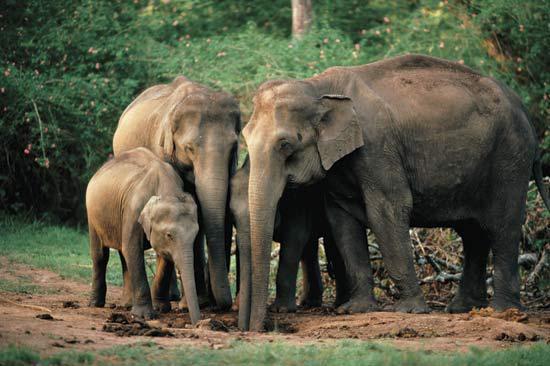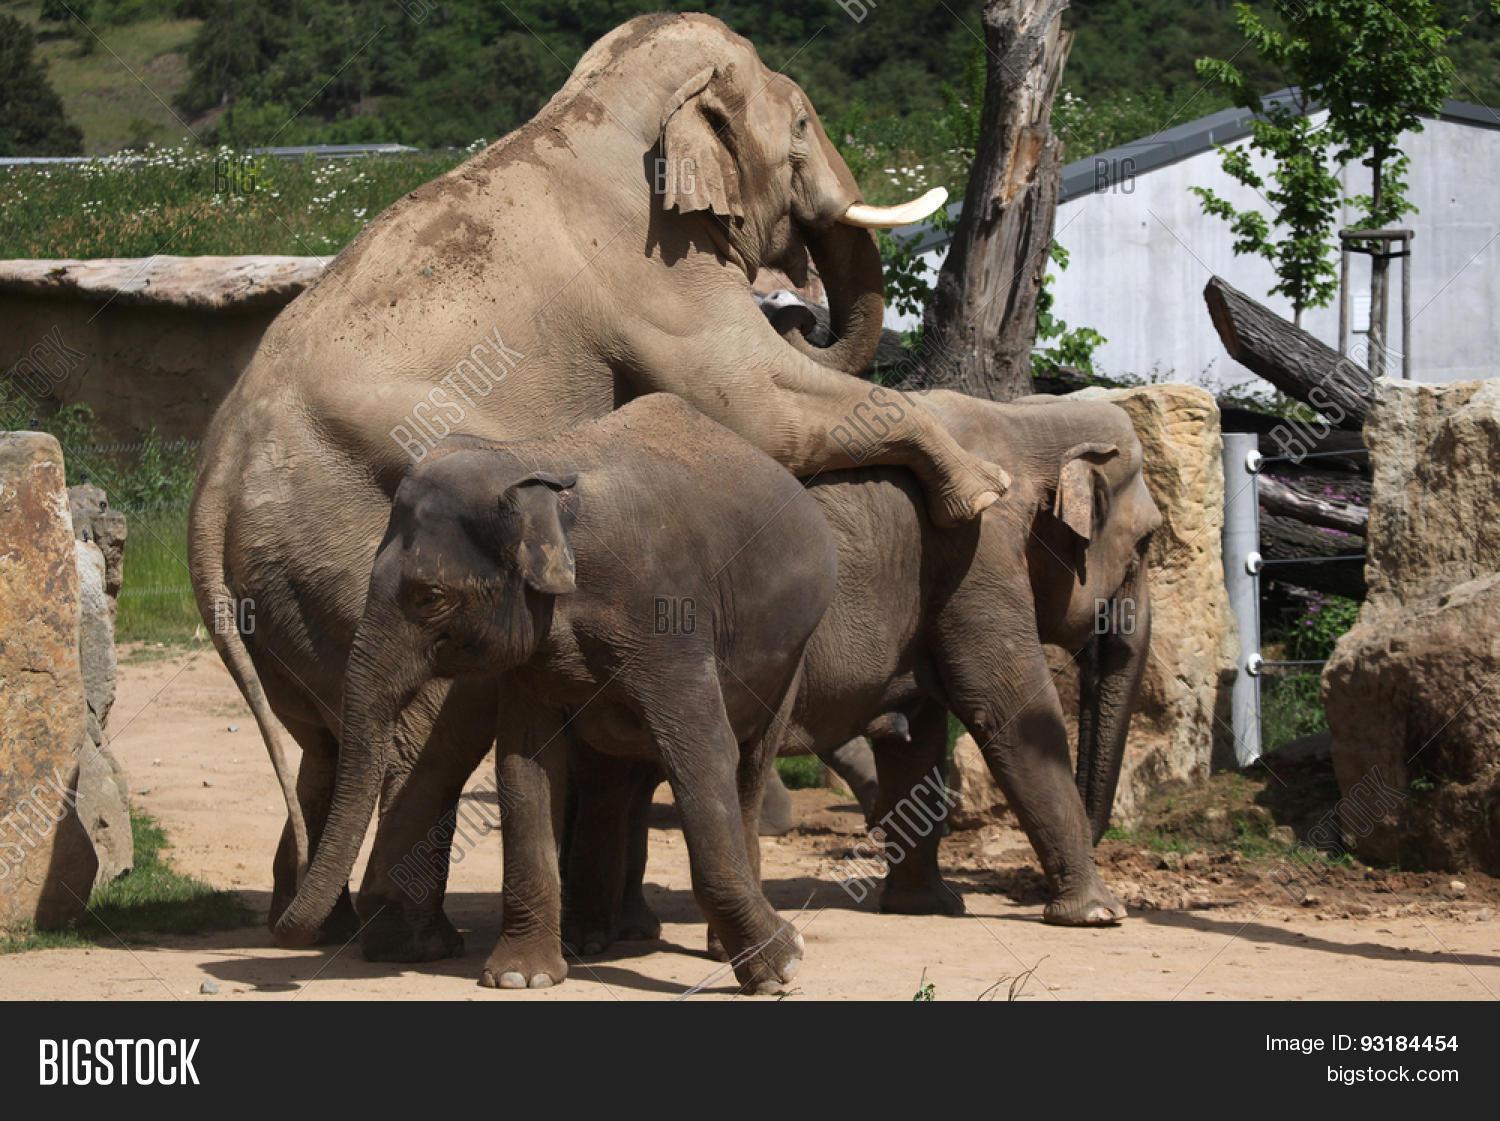The first image is the image on the left, the second image is the image on the right. Analyze the images presented: Is the assertion "There is a baby elephant among adult elephants." valid? Answer yes or no. Yes. 